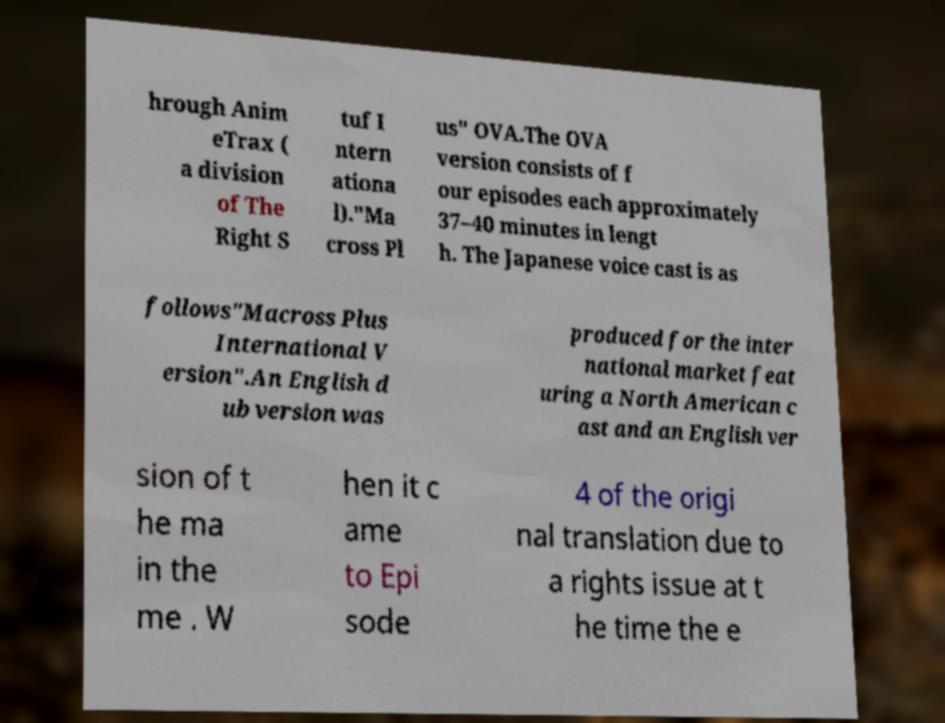Can you read and provide the text displayed in the image?This photo seems to have some interesting text. Can you extract and type it out for me? hrough Anim eTrax ( a division of The Right S tuf I ntern ationa l)."Ma cross Pl us" OVA.The OVA version consists of f our episodes each approximately 37–40 minutes in lengt h. The Japanese voice cast is as follows"Macross Plus International V ersion".An English d ub version was produced for the inter national market feat uring a North American c ast and an English ver sion of t he ma in the me . W hen it c ame to Epi sode 4 of the origi nal translation due to a rights issue at t he time the e 